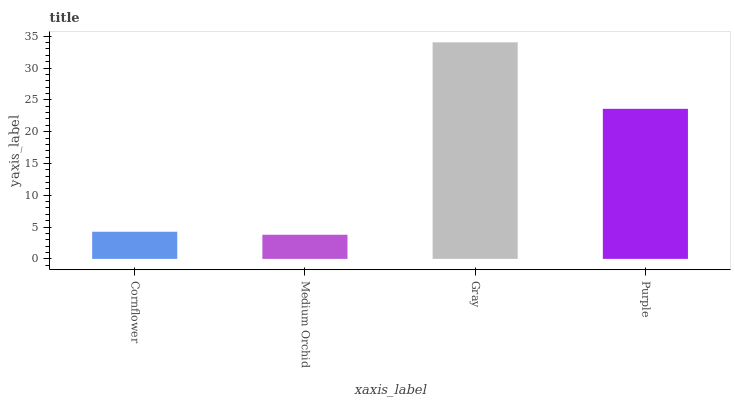Is Gray the minimum?
Answer yes or no. No. Is Medium Orchid the maximum?
Answer yes or no. No. Is Gray greater than Medium Orchid?
Answer yes or no. Yes. Is Medium Orchid less than Gray?
Answer yes or no. Yes. Is Medium Orchid greater than Gray?
Answer yes or no. No. Is Gray less than Medium Orchid?
Answer yes or no. No. Is Purple the high median?
Answer yes or no. Yes. Is Cornflower the low median?
Answer yes or no. Yes. Is Cornflower the high median?
Answer yes or no. No. Is Gray the low median?
Answer yes or no. No. 